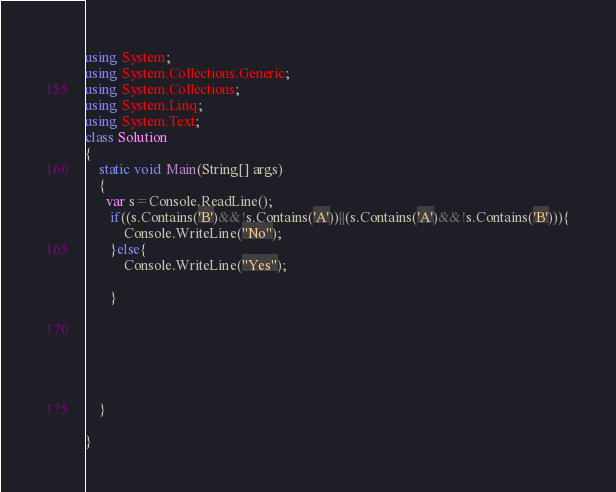Convert code to text. <code><loc_0><loc_0><loc_500><loc_500><_C#_>
using System;
using System.Collections.Generic;
using System.Collections;
using System.Linq;
using System.Text;
class Solution
{
    static void Main(String[] args)
    {
      var s=Console.ReadLine();
       if((s.Contains('B')&&!s.Contains('A'))||(s.Contains('A')&&!s.Contains('B'))){
           Console.WriteLine("No");
       }else{
           Console.WriteLine("Yes");

       }
        

           
            
             
 
    }
 
}</code> 